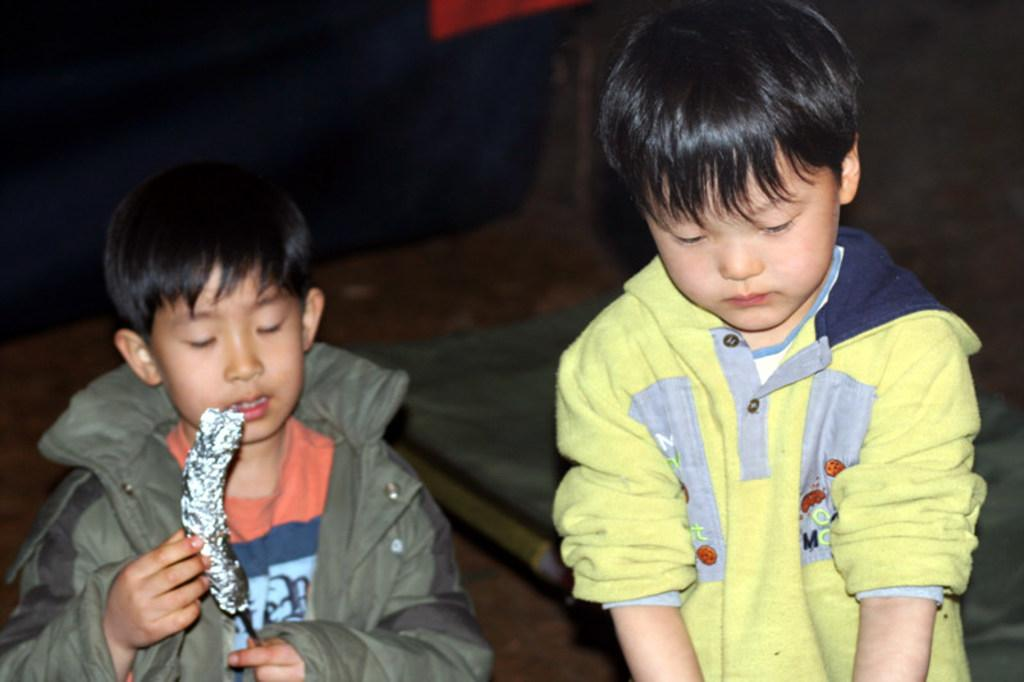How many boys are in the image? There are two boys in the foreground of the image. What is one of the boys doing in the image? One of the boys is holding an object. Can you describe the background of the image? The background of the image is not clear. What time of day is it in the image? The time of day cannot be determined from the image, as there is no information provided about the lighting or shadows. 